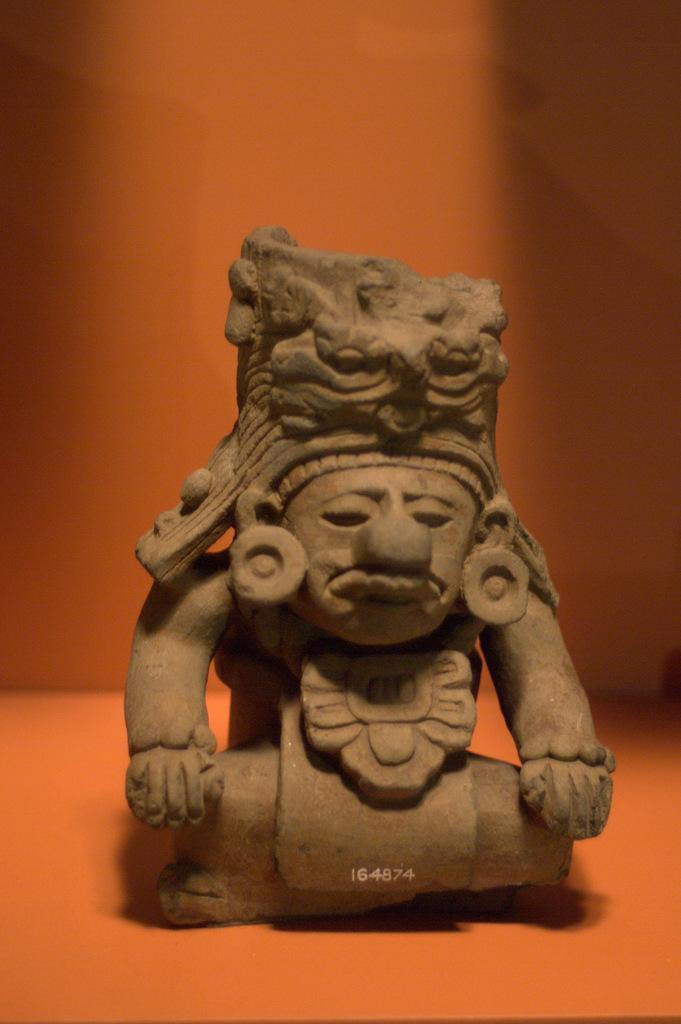In one or two sentences, can you explain what this image depicts? In this image there is a small statue on the floor. 